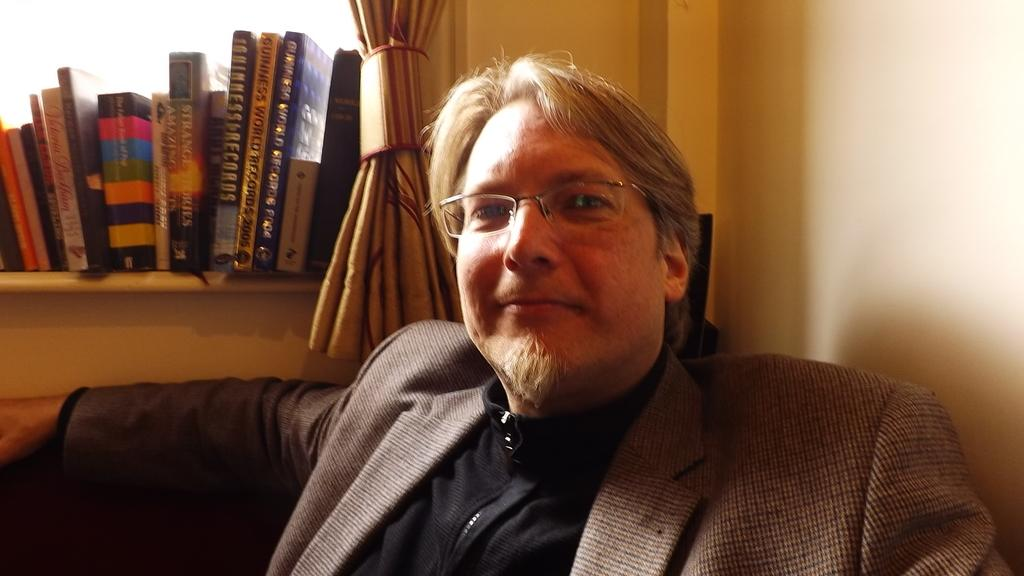What is the main subject of the image? There is a man in the image. Can you describe the man's appearance? The man is wearing clothes and spectacles. What is the man's facial expression? The man is smiling. What can be seen on the shelves in the image? There are books on a shelf in the image. What type of window treatment is present in the image? There are curtains in the image. What language is the fowl speaking in the image? There is no fowl present in the image, and therefore no language can be attributed to it. 